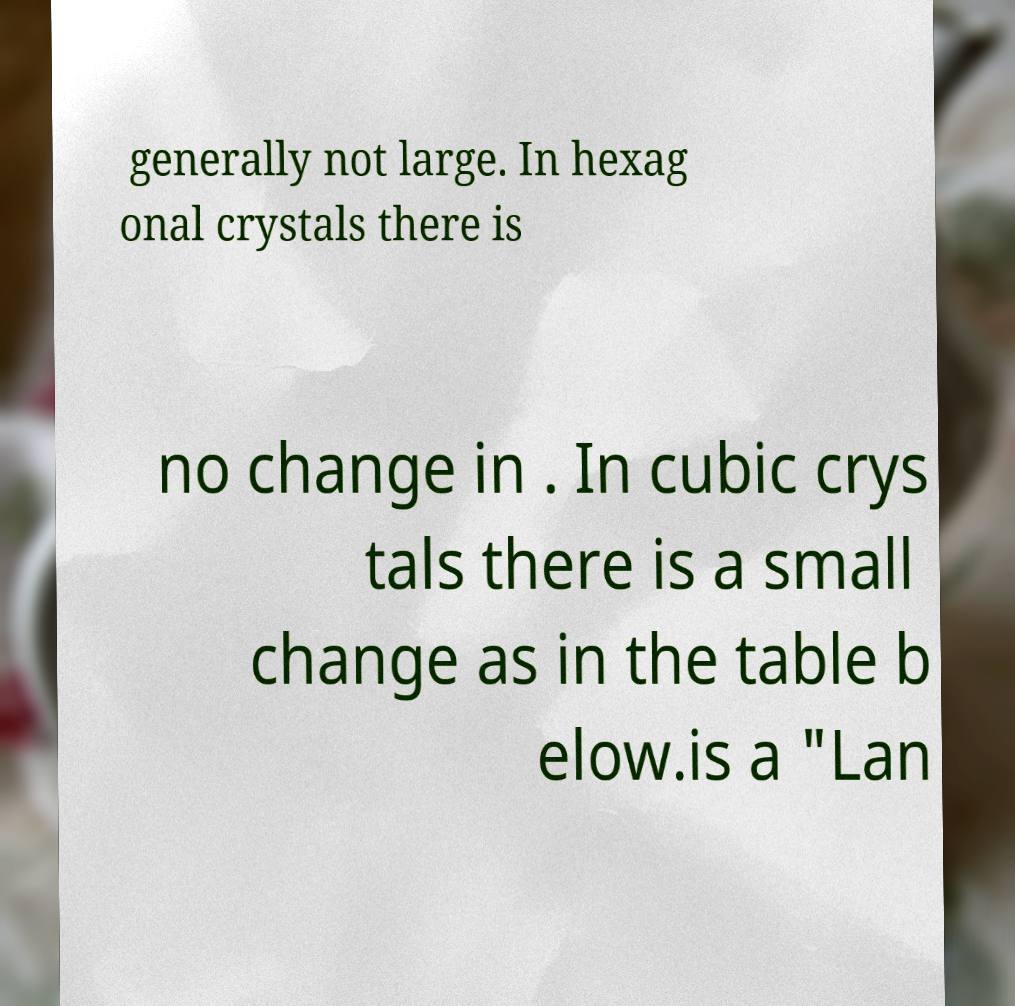Please read and relay the text visible in this image. What does it say? generally not large. In hexag onal crystals there is no change in . In cubic crys tals there is a small change as in the table b elow.is a "Lan 